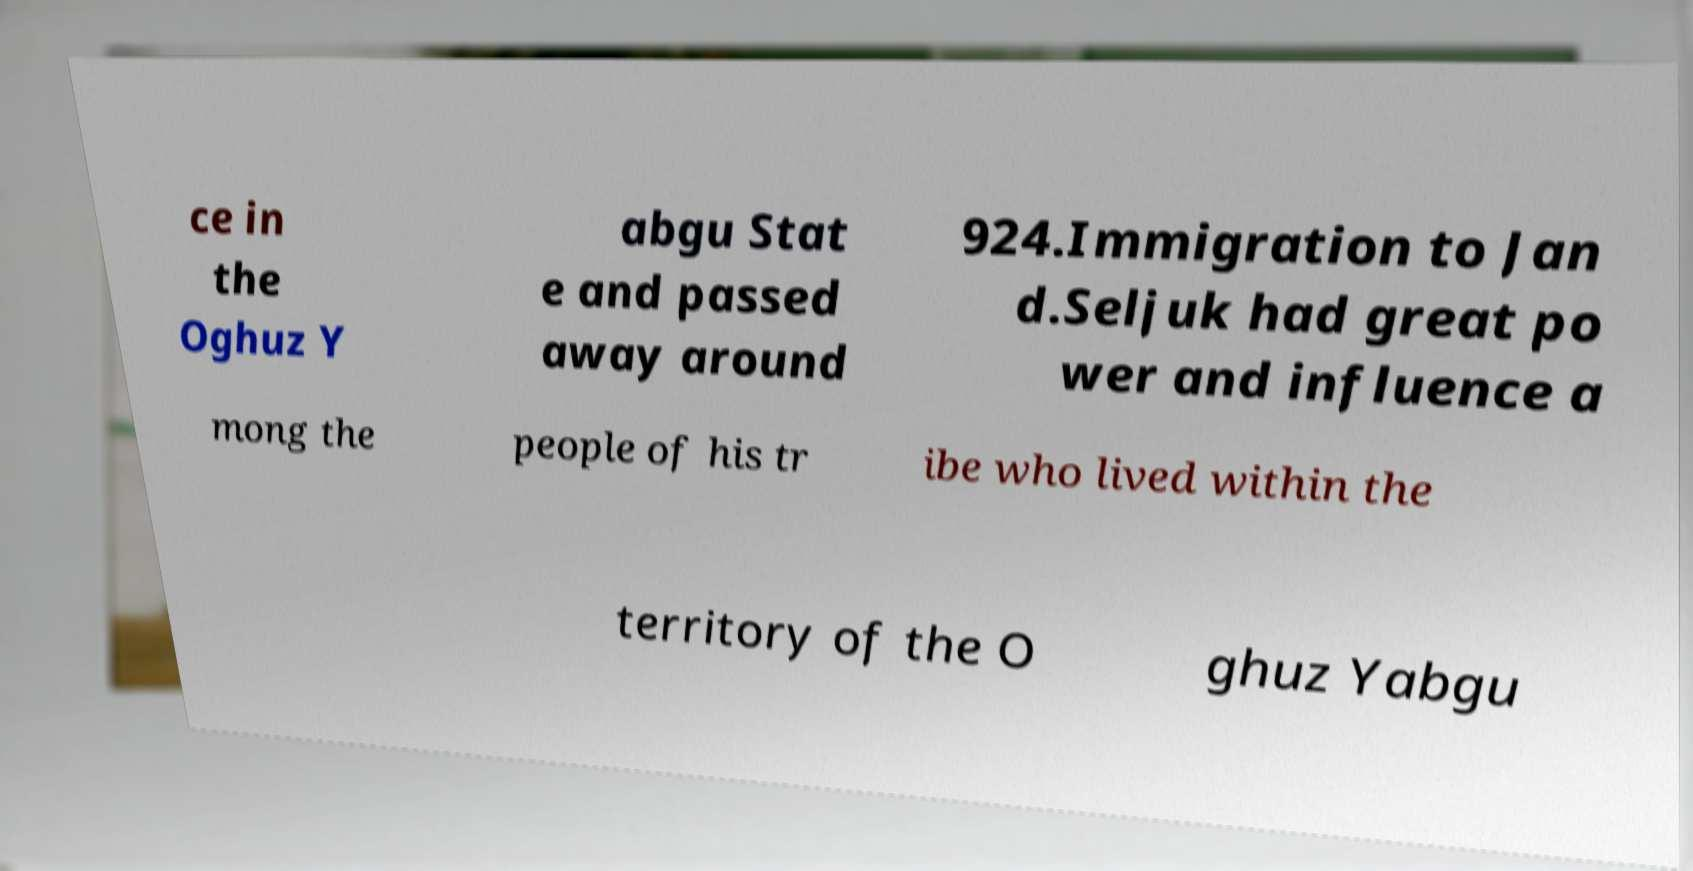Could you assist in decoding the text presented in this image and type it out clearly? ce in the Oghuz Y abgu Stat e and passed away around 924.Immigration to Jan d.Seljuk had great po wer and influence a mong the people of his tr ibe who lived within the territory of the O ghuz Yabgu 